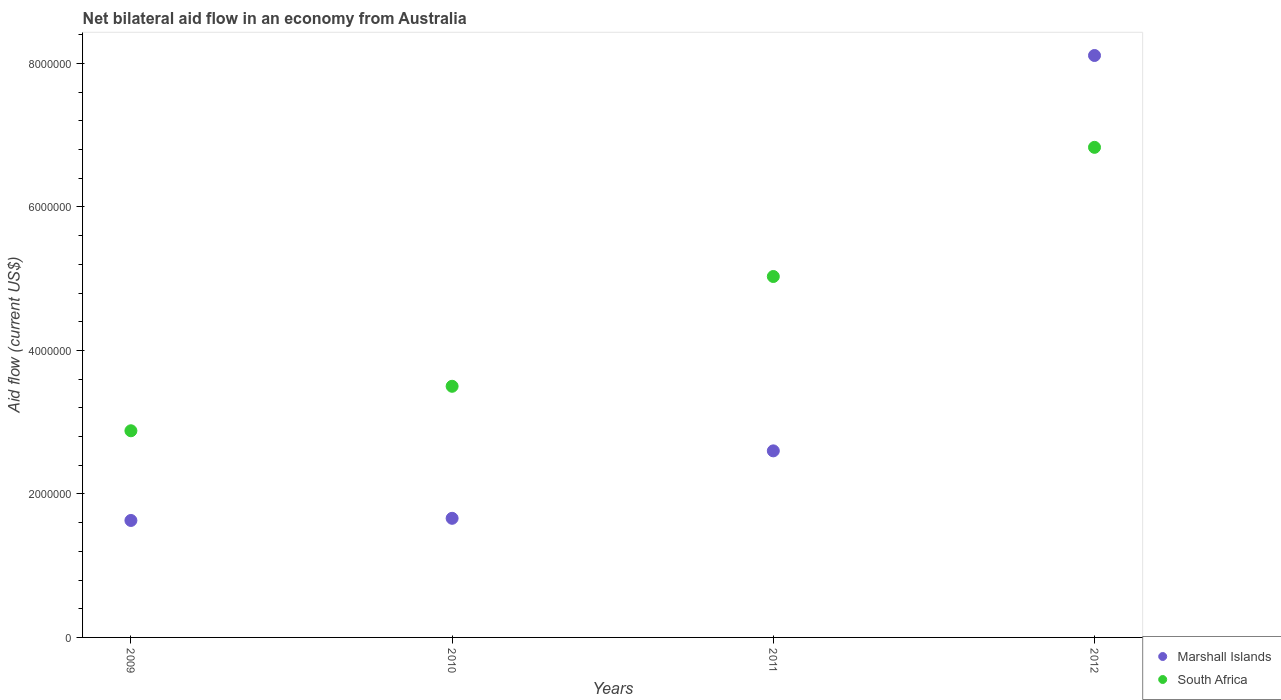Is the number of dotlines equal to the number of legend labels?
Give a very brief answer. Yes. What is the net bilateral aid flow in South Africa in 2011?
Your answer should be compact. 5.03e+06. Across all years, what is the maximum net bilateral aid flow in Marshall Islands?
Offer a very short reply. 8.11e+06. Across all years, what is the minimum net bilateral aid flow in South Africa?
Your answer should be very brief. 2.88e+06. In which year was the net bilateral aid flow in South Africa maximum?
Offer a terse response. 2012. In which year was the net bilateral aid flow in South Africa minimum?
Provide a succinct answer. 2009. What is the total net bilateral aid flow in Marshall Islands in the graph?
Offer a very short reply. 1.40e+07. What is the difference between the net bilateral aid flow in South Africa in 2010 and that in 2012?
Provide a short and direct response. -3.33e+06. What is the difference between the net bilateral aid flow in Marshall Islands in 2012 and the net bilateral aid flow in South Africa in 2009?
Make the answer very short. 5.23e+06. What is the average net bilateral aid flow in Marshall Islands per year?
Offer a very short reply. 3.50e+06. In the year 2009, what is the difference between the net bilateral aid flow in Marshall Islands and net bilateral aid flow in South Africa?
Provide a succinct answer. -1.25e+06. In how many years, is the net bilateral aid flow in Marshall Islands greater than 3600000 US$?
Keep it short and to the point. 1. What is the ratio of the net bilateral aid flow in Marshall Islands in 2009 to that in 2010?
Ensure brevity in your answer.  0.98. What is the difference between the highest and the second highest net bilateral aid flow in South Africa?
Ensure brevity in your answer.  1.80e+06. What is the difference between the highest and the lowest net bilateral aid flow in Marshall Islands?
Provide a succinct answer. 6.48e+06. Is the sum of the net bilateral aid flow in Marshall Islands in 2009 and 2011 greater than the maximum net bilateral aid flow in South Africa across all years?
Your answer should be compact. No. Does the net bilateral aid flow in Marshall Islands monotonically increase over the years?
Give a very brief answer. Yes. Is the net bilateral aid flow in Marshall Islands strictly greater than the net bilateral aid flow in South Africa over the years?
Ensure brevity in your answer.  No. What is the difference between two consecutive major ticks on the Y-axis?
Provide a succinct answer. 2.00e+06. Are the values on the major ticks of Y-axis written in scientific E-notation?
Keep it short and to the point. No. Does the graph contain any zero values?
Provide a succinct answer. No. Does the graph contain grids?
Your response must be concise. No. Where does the legend appear in the graph?
Ensure brevity in your answer.  Bottom right. How many legend labels are there?
Make the answer very short. 2. How are the legend labels stacked?
Your answer should be compact. Vertical. What is the title of the graph?
Ensure brevity in your answer.  Net bilateral aid flow in an economy from Australia. Does "American Samoa" appear as one of the legend labels in the graph?
Make the answer very short. No. What is the label or title of the X-axis?
Provide a short and direct response. Years. What is the Aid flow (current US$) in Marshall Islands in 2009?
Your answer should be compact. 1.63e+06. What is the Aid flow (current US$) of South Africa in 2009?
Offer a very short reply. 2.88e+06. What is the Aid flow (current US$) in Marshall Islands in 2010?
Offer a terse response. 1.66e+06. What is the Aid flow (current US$) in South Africa in 2010?
Offer a very short reply. 3.50e+06. What is the Aid flow (current US$) in Marshall Islands in 2011?
Your answer should be compact. 2.60e+06. What is the Aid flow (current US$) in South Africa in 2011?
Make the answer very short. 5.03e+06. What is the Aid flow (current US$) of Marshall Islands in 2012?
Make the answer very short. 8.11e+06. What is the Aid flow (current US$) in South Africa in 2012?
Provide a short and direct response. 6.83e+06. Across all years, what is the maximum Aid flow (current US$) in Marshall Islands?
Make the answer very short. 8.11e+06. Across all years, what is the maximum Aid flow (current US$) in South Africa?
Your answer should be very brief. 6.83e+06. Across all years, what is the minimum Aid flow (current US$) in Marshall Islands?
Ensure brevity in your answer.  1.63e+06. Across all years, what is the minimum Aid flow (current US$) of South Africa?
Provide a short and direct response. 2.88e+06. What is the total Aid flow (current US$) in Marshall Islands in the graph?
Your response must be concise. 1.40e+07. What is the total Aid flow (current US$) of South Africa in the graph?
Provide a short and direct response. 1.82e+07. What is the difference between the Aid flow (current US$) of South Africa in 2009 and that in 2010?
Provide a short and direct response. -6.20e+05. What is the difference between the Aid flow (current US$) of Marshall Islands in 2009 and that in 2011?
Give a very brief answer. -9.70e+05. What is the difference between the Aid flow (current US$) of South Africa in 2009 and that in 2011?
Provide a short and direct response. -2.15e+06. What is the difference between the Aid flow (current US$) in Marshall Islands in 2009 and that in 2012?
Your answer should be compact. -6.48e+06. What is the difference between the Aid flow (current US$) of South Africa in 2009 and that in 2012?
Make the answer very short. -3.95e+06. What is the difference between the Aid flow (current US$) in Marshall Islands in 2010 and that in 2011?
Provide a succinct answer. -9.40e+05. What is the difference between the Aid flow (current US$) in South Africa in 2010 and that in 2011?
Your answer should be compact. -1.53e+06. What is the difference between the Aid flow (current US$) in Marshall Islands in 2010 and that in 2012?
Make the answer very short. -6.45e+06. What is the difference between the Aid flow (current US$) of South Africa in 2010 and that in 2012?
Your response must be concise. -3.33e+06. What is the difference between the Aid flow (current US$) of Marshall Islands in 2011 and that in 2012?
Ensure brevity in your answer.  -5.51e+06. What is the difference between the Aid flow (current US$) of South Africa in 2011 and that in 2012?
Keep it short and to the point. -1.80e+06. What is the difference between the Aid flow (current US$) of Marshall Islands in 2009 and the Aid flow (current US$) of South Africa in 2010?
Keep it short and to the point. -1.87e+06. What is the difference between the Aid flow (current US$) in Marshall Islands in 2009 and the Aid flow (current US$) in South Africa in 2011?
Give a very brief answer. -3.40e+06. What is the difference between the Aid flow (current US$) in Marshall Islands in 2009 and the Aid flow (current US$) in South Africa in 2012?
Offer a terse response. -5.20e+06. What is the difference between the Aid flow (current US$) in Marshall Islands in 2010 and the Aid flow (current US$) in South Africa in 2011?
Your answer should be very brief. -3.37e+06. What is the difference between the Aid flow (current US$) of Marshall Islands in 2010 and the Aid flow (current US$) of South Africa in 2012?
Make the answer very short. -5.17e+06. What is the difference between the Aid flow (current US$) in Marshall Islands in 2011 and the Aid flow (current US$) in South Africa in 2012?
Give a very brief answer. -4.23e+06. What is the average Aid flow (current US$) of Marshall Islands per year?
Give a very brief answer. 3.50e+06. What is the average Aid flow (current US$) of South Africa per year?
Ensure brevity in your answer.  4.56e+06. In the year 2009, what is the difference between the Aid flow (current US$) of Marshall Islands and Aid flow (current US$) of South Africa?
Keep it short and to the point. -1.25e+06. In the year 2010, what is the difference between the Aid flow (current US$) of Marshall Islands and Aid flow (current US$) of South Africa?
Offer a very short reply. -1.84e+06. In the year 2011, what is the difference between the Aid flow (current US$) in Marshall Islands and Aid flow (current US$) in South Africa?
Make the answer very short. -2.43e+06. In the year 2012, what is the difference between the Aid flow (current US$) in Marshall Islands and Aid flow (current US$) in South Africa?
Provide a short and direct response. 1.28e+06. What is the ratio of the Aid flow (current US$) of Marshall Islands in 2009 to that in 2010?
Your answer should be compact. 0.98. What is the ratio of the Aid flow (current US$) of South Africa in 2009 to that in 2010?
Offer a very short reply. 0.82. What is the ratio of the Aid flow (current US$) in Marshall Islands in 2009 to that in 2011?
Provide a succinct answer. 0.63. What is the ratio of the Aid flow (current US$) of South Africa in 2009 to that in 2011?
Keep it short and to the point. 0.57. What is the ratio of the Aid flow (current US$) of Marshall Islands in 2009 to that in 2012?
Offer a very short reply. 0.2. What is the ratio of the Aid flow (current US$) of South Africa in 2009 to that in 2012?
Provide a short and direct response. 0.42. What is the ratio of the Aid flow (current US$) in Marshall Islands in 2010 to that in 2011?
Your response must be concise. 0.64. What is the ratio of the Aid flow (current US$) in South Africa in 2010 to that in 2011?
Make the answer very short. 0.7. What is the ratio of the Aid flow (current US$) of Marshall Islands in 2010 to that in 2012?
Ensure brevity in your answer.  0.2. What is the ratio of the Aid flow (current US$) in South Africa in 2010 to that in 2012?
Provide a succinct answer. 0.51. What is the ratio of the Aid flow (current US$) in Marshall Islands in 2011 to that in 2012?
Ensure brevity in your answer.  0.32. What is the ratio of the Aid flow (current US$) of South Africa in 2011 to that in 2012?
Offer a terse response. 0.74. What is the difference between the highest and the second highest Aid flow (current US$) in Marshall Islands?
Give a very brief answer. 5.51e+06. What is the difference between the highest and the second highest Aid flow (current US$) in South Africa?
Offer a very short reply. 1.80e+06. What is the difference between the highest and the lowest Aid flow (current US$) in Marshall Islands?
Provide a short and direct response. 6.48e+06. What is the difference between the highest and the lowest Aid flow (current US$) in South Africa?
Make the answer very short. 3.95e+06. 